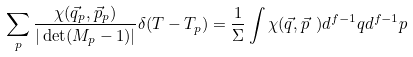Convert formula to latex. <formula><loc_0><loc_0><loc_500><loc_500>\sum _ { p } \frac { \chi ( \vec { q } _ { p } , \vec { p } _ { p } ) } { | \det ( M _ { p } - 1 ) | } \delta ( T - T _ { p } ) = \frac { 1 } { \Sigma } \int \chi ( \vec { q } , \vec { p } \ ) d ^ { f - 1 } q d ^ { f - 1 } p</formula> 